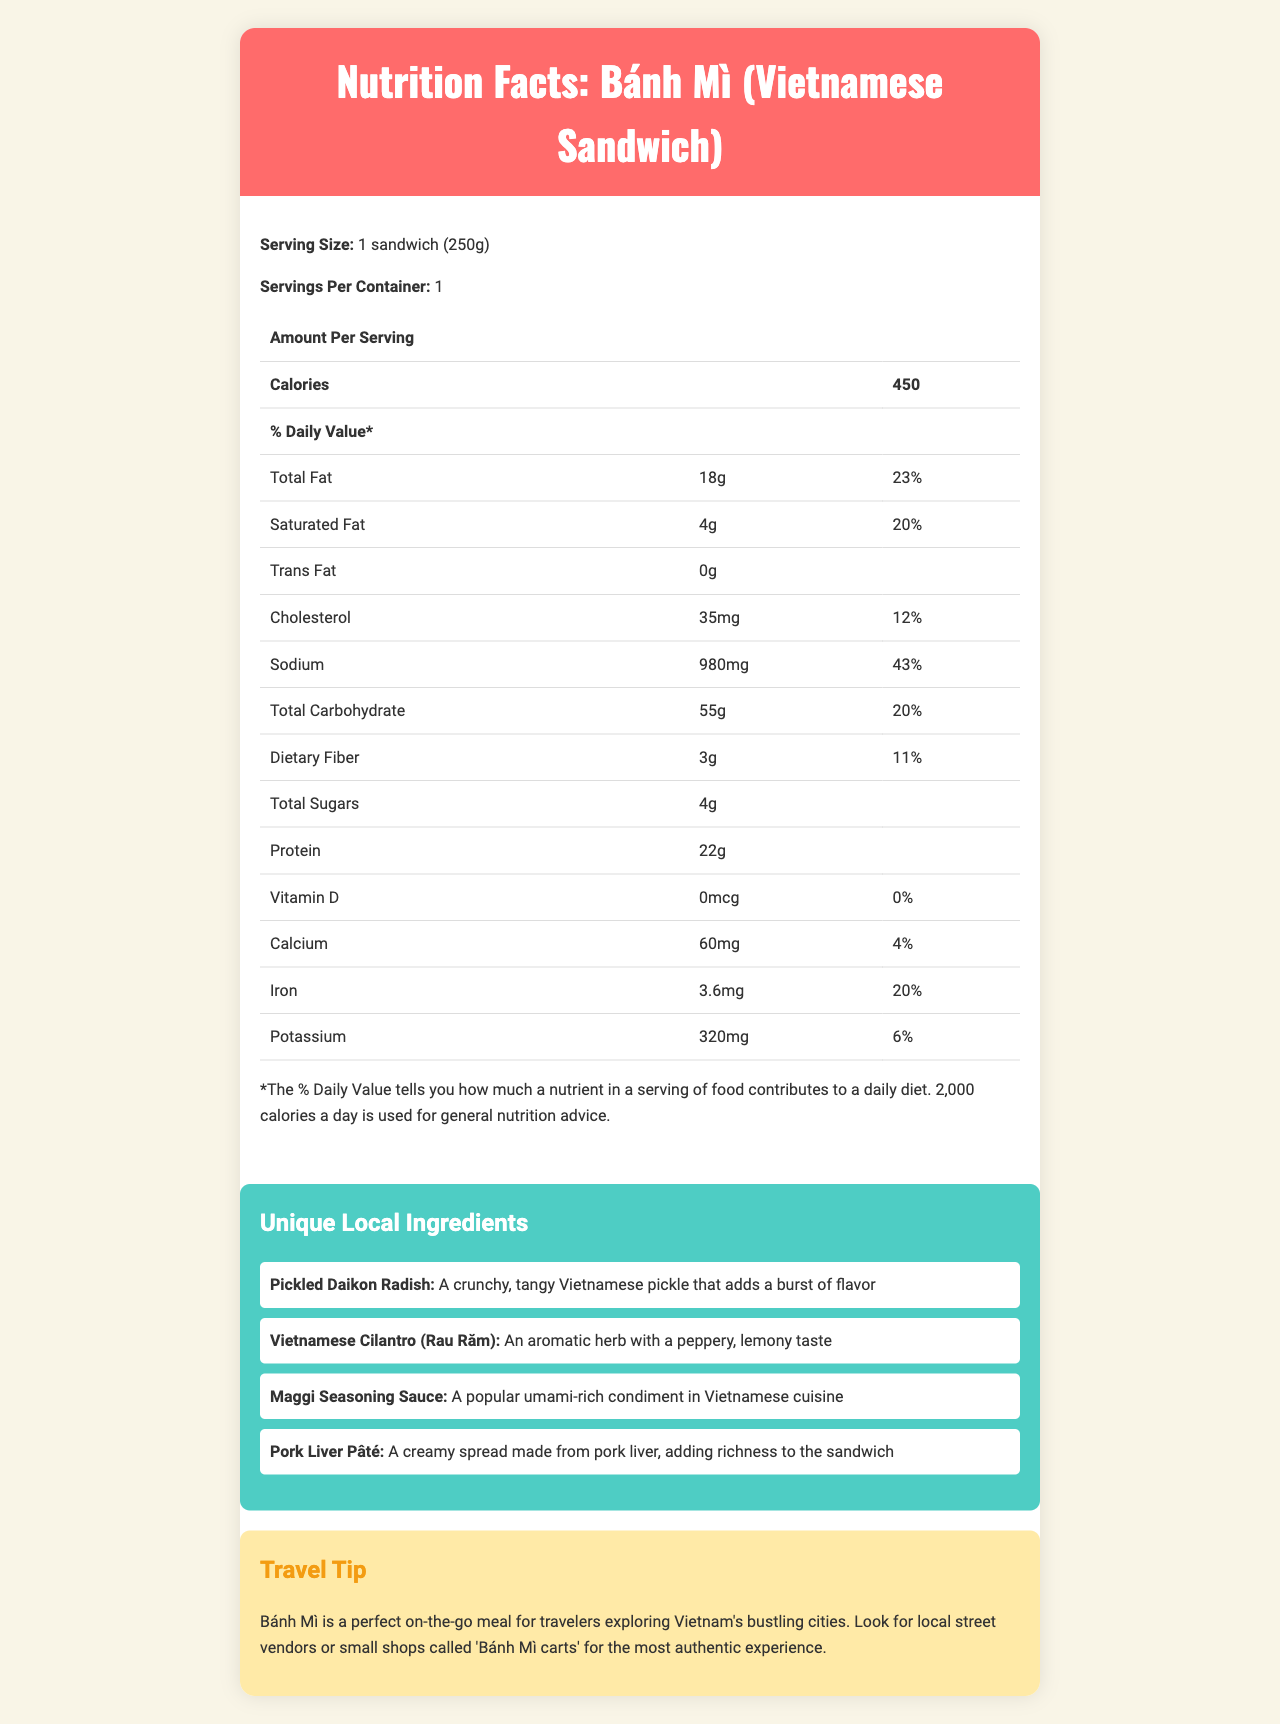what is the serving size of Bánh Mì? The document explicitly states that the serving size is 1 sandwich weighing 250g.
Answer: 1 sandwich (250g) how many grams of saturated fat are there per serving? The nutrition facts label indicates that there are 4 grams of saturated fat per serving.
Answer: 4g how much protein does a serving provide? The document lists protein content as 22 grams per serving.
Answer: 22g what is the daily value percentage for sodium? The nutrition facts label shows that the sodium content provides 43% of the daily value.
Answer: 43% what is the purpose of Maggi Seasoning Sauce in the sandwich? The unique local ingredients section describes Maggi Seasoning Sauce as a popular umami-rich condiment in Vietnamese cuisine.
Answer: It is a popular umami-rich condiment in Vietnamese cuisine. how much calcium is in a serving of Bánh Mì? The label states that there are 60mg of calcium per serving.
Answer: 60mg How much total carbohydrate does a serving of Bánh Mì contain? A. 20g B. 30g C. 55g D. 75g The document shows that a serving contains 55g of total carbohydrate.
Answer: C. 55g What is the total fat content in a serving of Bánh Mì? A. 10g B. 18g C. 25g D. 30g The nutrition facts list total fat as 18g per serving.
Answer: B. 18g Is Pork Liver Pâté described as adding a creamy or spicy flavor to the Bánh Mì? The document describes Pork Liver Pâté as adding a creamy texture to the sandwich.
Answer: Creamy Does the Bánh Mì contain any trans fat? The nutrition facts label indicates that the sandwich contains 0g of trans fat.
Answer: No summarize the key information about Bánh Mì provided in the document. The document includes comprehensive nutrition data, a list of special local ingredients, and a travel tip for experiencing Bánh Mì authentically.
Answer: The document provides the nutrition facts for a Bánh Mì, detailing its serving size, calorie content, and percentages of daily values for various nutrients. It also highlights unique local ingredients like Pickled Daikon Radish, Vietnamese Cilantro, Maggi Seasoning Sauce, and Pork Liver Pâté, along with a travel tip for enjoying the sandwich in Vietnam. what is the preparation time for the Bánh Mì? The document does not provide any information regarding the preparation time for the Bánh Mì.
Answer: Cannot be determined 